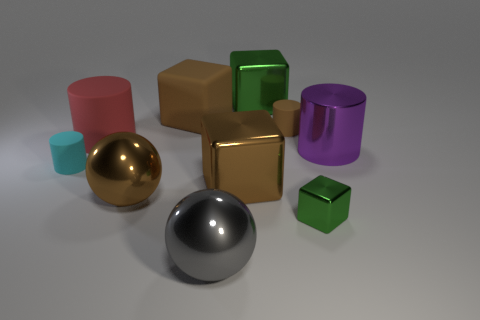Subtract 1 blocks. How many blocks are left? 3 Subtract all balls. How many objects are left? 8 Add 5 cylinders. How many cylinders exist? 9 Subtract 0 gray cylinders. How many objects are left? 10 Subtract all purple blocks. Subtract all purple cylinders. How many objects are left? 9 Add 3 brown metallic objects. How many brown metallic objects are left? 5 